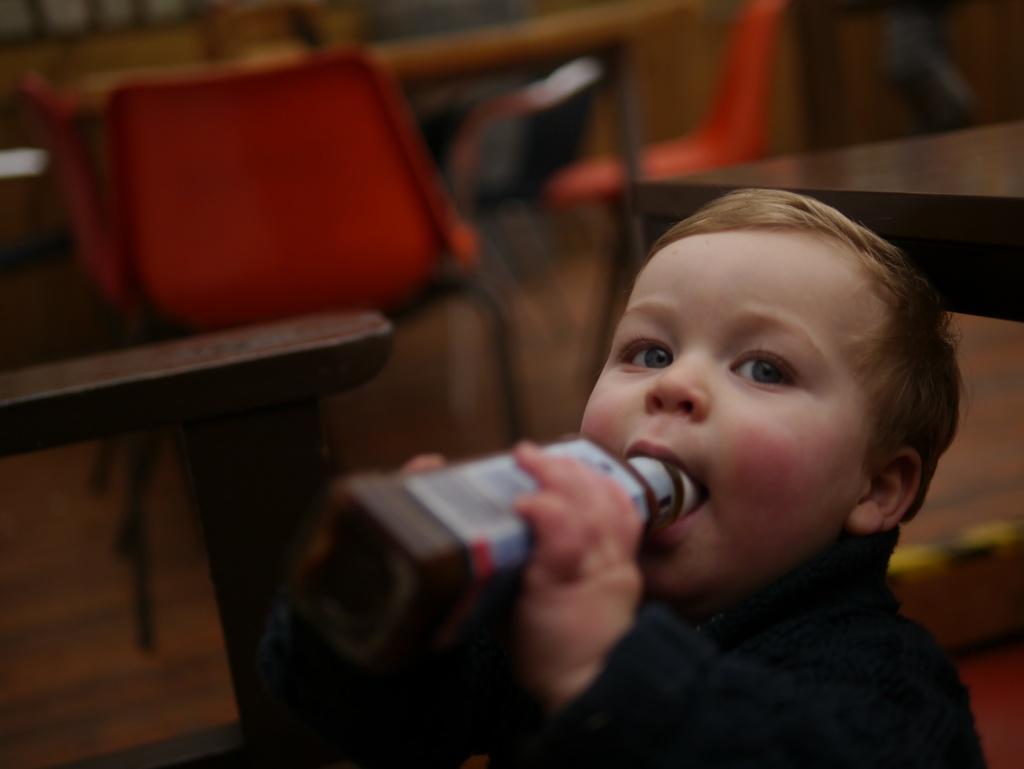Could you give a brief overview of what you see in this image? In this picture there is a boy with dark blue sweatshirt is holding the bottle. At the back there are orange color chairs and there are tables. 